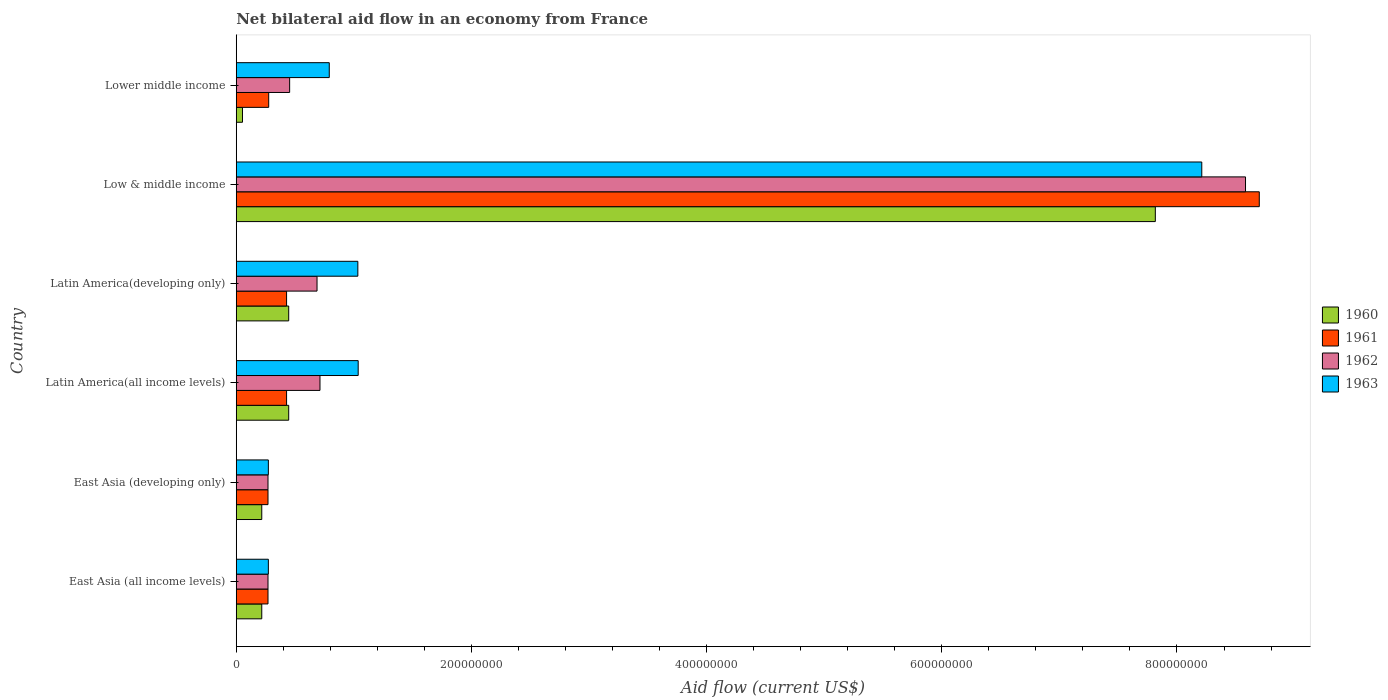How many groups of bars are there?
Offer a terse response. 6. Are the number of bars on each tick of the Y-axis equal?
Provide a short and direct response. Yes. How many bars are there on the 4th tick from the top?
Your response must be concise. 4. How many bars are there on the 6th tick from the bottom?
Provide a succinct answer. 4. What is the label of the 5th group of bars from the top?
Provide a succinct answer. East Asia (developing only). What is the net bilateral aid flow in 1961 in Lower middle income?
Keep it short and to the point. 2.76e+07. Across all countries, what is the maximum net bilateral aid flow in 1961?
Your answer should be very brief. 8.70e+08. Across all countries, what is the minimum net bilateral aid flow in 1963?
Give a very brief answer. 2.73e+07. In which country was the net bilateral aid flow in 1960 minimum?
Make the answer very short. Lower middle income. What is the total net bilateral aid flow in 1961 in the graph?
Offer a terse response. 1.04e+09. What is the difference between the net bilateral aid flow in 1961 in Latin America(all income levels) and the net bilateral aid flow in 1960 in Latin America(developing only)?
Provide a short and direct response. -1.80e+06. What is the average net bilateral aid flow in 1963 per country?
Provide a short and direct response. 1.94e+08. What is the difference between the net bilateral aid flow in 1961 and net bilateral aid flow in 1962 in Low & middle income?
Make the answer very short. 1.17e+07. What is the ratio of the net bilateral aid flow in 1962 in Latin America(all income levels) to that in Low & middle income?
Your answer should be very brief. 0.08. What is the difference between the highest and the second highest net bilateral aid flow in 1961?
Your response must be concise. 8.27e+08. What is the difference between the highest and the lowest net bilateral aid flow in 1962?
Give a very brief answer. 8.31e+08. Is the sum of the net bilateral aid flow in 1963 in East Asia (developing only) and Latin America(all income levels) greater than the maximum net bilateral aid flow in 1961 across all countries?
Provide a short and direct response. No. Is it the case that in every country, the sum of the net bilateral aid flow in 1961 and net bilateral aid flow in 1963 is greater than the sum of net bilateral aid flow in 1962 and net bilateral aid flow in 1960?
Give a very brief answer. No. How many bars are there?
Provide a succinct answer. 24. Are the values on the major ticks of X-axis written in scientific E-notation?
Your answer should be very brief. No. Does the graph contain any zero values?
Ensure brevity in your answer.  No. Does the graph contain grids?
Offer a very short reply. No. What is the title of the graph?
Your answer should be very brief. Net bilateral aid flow in an economy from France. Does "1986" appear as one of the legend labels in the graph?
Give a very brief answer. No. What is the Aid flow (current US$) of 1960 in East Asia (all income levels)?
Make the answer very short. 2.17e+07. What is the Aid flow (current US$) in 1961 in East Asia (all income levels)?
Offer a very short reply. 2.70e+07. What is the Aid flow (current US$) of 1962 in East Asia (all income levels)?
Keep it short and to the point. 2.70e+07. What is the Aid flow (current US$) in 1963 in East Asia (all income levels)?
Your response must be concise. 2.73e+07. What is the Aid flow (current US$) of 1960 in East Asia (developing only)?
Provide a short and direct response. 2.17e+07. What is the Aid flow (current US$) of 1961 in East Asia (developing only)?
Ensure brevity in your answer.  2.70e+07. What is the Aid flow (current US$) of 1962 in East Asia (developing only)?
Give a very brief answer. 2.70e+07. What is the Aid flow (current US$) of 1963 in East Asia (developing only)?
Provide a succinct answer. 2.73e+07. What is the Aid flow (current US$) of 1960 in Latin America(all income levels)?
Provide a short and direct response. 4.46e+07. What is the Aid flow (current US$) in 1961 in Latin America(all income levels)?
Make the answer very short. 4.28e+07. What is the Aid flow (current US$) of 1962 in Latin America(all income levels)?
Offer a terse response. 7.12e+07. What is the Aid flow (current US$) of 1963 in Latin America(all income levels)?
Your answer should be compact. 1.04e+08. What is the Aid flow (current US$) in 1960 in Latin America(developing only)?
Provide a succinct answer. 4.46e+07. What is the Aid flow (current US$) of 1961 in Latin America(developing only)?
Ensure brevity in your answer.  4.28e+07. What is the Aid flow (current US$) in 1962 in Latin America(developing only)?
Your answer should be very brief. 6.87e+07. What is the Aid flow (current US$) of 1963 in Latin America(developing only)?
Provide a short and direct response. 1.03e+08. What is the Aid flow (current US$) of 1960 in Low & middle income?
Offer a very short reply. 7.82e+08. What is the Aid flow (current US$) of 1961 in Low & middle income?
Ensure brevity in your answer.  8.70e+08. What is the Aid flow (current US$) in 1962 in Low & middle income?
Provide a short and direct response. 8.58e+08. What is the Aid flow (current US$) of 1963 in Low & middle income?
Your answer should be very brief. 8.21e+08. What is the Aid flow (current US$) in 1960 in Lower middle income?
Give a very brief answer. 5.30e+06. What is the Aid flow (current US$) in 1961 in Lower middle income?
Ensure brevity in your answer.  2.76e+07. What is the Aid flow (current US$) in 1962 in Lower middle income?
Your response must be concise. 4.54e+07. What is the Aid flow (current US$) in 1963 in Lower middle income?
Offer a very short reply. 7.91e+07. Across all countries, what is the maximum Aid flow (current US$) in 1960?
Provide a succinct answer. 7.82e+08. Across all countries, what is the maximum Aid flow (current US$) in 1961?
Provide a succinct answer. 8.70e+08. Across all countries, what is the maximum Aid flow (current US$) in 1962?
Keep it short and to the point. 8.58e+08. Across all countries, what is the maximum Aid flow (current US$) in 1963?
Ensure brevity in your answer.  8.21e+08. Across all countries, what is the minimum Aid flow (current US$) of 1960?
Your answer should be very brief. 5.30e+06. Across all countries, what is the minimum Aid flow (current US$) in 1961?
Provide a succinct answer. 2.70e+07. Across all countries, what is the minimum Aid flow (current US$) in 1962?
Your answer should be very brief. 2.70e+07. Across all countries, what is the minimum Aid flow (current US$) in 1963?
Make the answer very short. 2.73e+07. What is the total Aid flow (current US$) of 1960 in the graph?
Give a very brief answer. 9.20e+08. What is the total Aid flow (current US$) of 1961 in the graph?
Give a very brief answer. 1.04e+09. What is the total Aid flow (current US$) of 1962 in the graph?
Keep it short and to the point. 1.10e+09. What is the total Aid flow (current US$) of 1963 in the graph?
Make the answer very short. 1.16e+09. What is the difference between the Aid flow (current US$) in 1961 in East Asia (all income levels) and that in East Asia (developing only)?
Ensure brevity in your answer.  0. What is the difference between the Aid flow (current US$) in 1963 in East Asia (all income levels) and that in East Asia (developing only)?
Your answer should be very brief. 0. What is the difference between the Aid flow (current US$) in 1960 in East Asia (all income levels) and that in Latin America(all income levels)?
Provide a succinct answer. -2.29e+07. What is the difference between the Aid flow (current US$) in 1961 in East Asia (all income levels) and that in Latin America(all income levels)?
Give a very brief answer. -1.58e+07. What is the difference between the Aid flow (current US$) of 1962 in East Asia (all income levels) and that in Latin America(all income levels)?
Provide a succinct answer. -4.42e+07. What is the difference between the Aid flow (current US$) in 1963 in East Asia (all income levels) and that in Latin America(all income levels)?
Offer a terse response. -7.64e+07. What is the difference between the Aid flow (current US$) of 1960 in East Asia (all income levels) and that in Latin America(developing only)?
Provide a succinct answer. -2.29e+07. What is the difference between the Aid flow (current US$) in 1961 in East Asia (all income levels) and that in Latin America(developing only)?
Ensure brevity in your answer.  -1.58e+07. What is the difference between the Aid flow (current US$) of 1962 in East Asia (all income levels) and that in Latin America(developing only)?
Provide a succinct answer. -4.17e+07. What is the difference between the Aid flow (current US$) in 1963 in East Asia (all income levels) and that in Latin America(developing only)?
Your answer should be very brief. -7.61e+07. What is the difference between the Aid flow (current US$) of 1960 in East Asia (all income levels) and that in Low & middle income?
Provide a succinct answer. -7.60e+08. What is the difference between the Aid flow (current US$) of 1961 in East Asia (all income levels) and that in Low & middle income?
Ensure brevity in your answer.  -8.43e+08. What is the difference between the Aid flow (current US$) in 1962 in East Asia (all income levels) and that in Low & middle income?
Offer a terse response. -8.31e+08. What is the difference between the Aid flow (current US$) of 1963 in East Asia (all income levels) and that in Low & middle income?
Give a very brief answer. -7.94e+08. What is the difference between the Aid flow (current US$) in 1960 in East Asia (all income levels) and that in Lower middle income?
Make the answer very short. 1.64e+07. What is the difference between the Aid flow (current US$) of 1961 in East Asia (all income levels) and that in Lower middle income?
Make the answer very short. -6.00e+05. What is the difference between the Aid flow (current US$) in 1962 in East Asia (all income levels) and that in Lower middle income?
Your response must be concise. -1.84e+07. What is the difference between the Aid flow (current US$) of 1963 in East Asia (all income levels) and that in Lower middle income?
Your answer should be very brief. -5.18e+07. What is the difference between the Aid flow (current US$) of 1960 in East Asia (developing only) and that in Latin America(all income levels)?
Your answer should be very brief. -2.29e+07. What is the difference between the Aid flow (current US$) in 1961 in East Asia (developing only) and that in Latin America(all income levels)?
Your answer should be compact. -1.58e+07. What is the difference between the Aid flow (current US$) in 1962 in East Asia (developing only) and that in Latin America(all income levels)?
Offer a very short reply. -4.42e+07. What is the difference between the Aid flow (current US$) in 1963 in East Asia (developing only) and that in Latin America(all income levels)?
Provide a short and direct response. -7.64e+07. What is the difference between the Aid flow (current US$) of 1960 in East Asia (developing only) and that in Latin America(developing only)?
Give a very brief answer. -2.29e+07. What is the difference between the Aid flow (current US$) of 1961 in East Asia (developing only) and that in Latin America(developing only)?
Ensure brevity in your answer.  -1.58e+07. What is the difference between the Aid flow (current US$) of 1962 in East Asia (developing only) and that in Latin America(developing only)?
Your answer should be very brief. -4.17e+07. What is the difference between the Aid flow (current US$) in 1963 in East Asia (developing only) and that in Latin America(developing only)?
Your answer should be compact. -7.61e+07. What is the difference between the Aid flow (current US$) of 1960 in East Asia (developing only) and that in Low & middle income?
Keep it short and to the point. -7.60e+08. What is the difference between the Aid flow (current US$) in 1961 in East Asia (developing only) and that in Low & middle income?
Provide a succinct answer. -8.43e+08. What is the difference between the Aid flow (current US$) of 1962 in East Asia (developing only) and that in Low & middle income?
Your response must be concise. -8.31e+08. What is the difference between the Aid flow (current US$) in 1963 in East Asia (developing only) and that in Low & middle income?
Your answer should be very brief. -7.94e+08. What is the difference between the Aid flow (current US$) in 1960 in East Asia (developing only) and that in Lower middle income?
Your answer should be very brief. 1.64e+07. What is the difference between the Aid flow (current US$) in 1961 in East Asia (developing only) and that in Lower middle income?
Provide a short and direct response. -6.00e+05. What is the difference between the Aid flow (current US$) of 1962 in East Asia (developing only) and that in Lower middle income?
Your answer should be compact. -1.84e+07. What is the difference between the Aid flow (current US$) of 1963 in East Asia (developing only) and that in Lower middle income?
Offer a very short reply. -5.18e+07. What is the difference between the Aid flow (current US$) of 1960 in Latin America(all income levels) and that in Latin America(developing only)?
Give a very brief answer. 0. What is the difference between the Aid flow (current US$) of 1961 in Latin America(all income levels) and that in Latin America(developing only)?
Provide a succinct answer. 0. What is the difference between the Aid flow (current US$) in 1962 in Latin America(all income levels) and that in Latin America(developing only)?
Provide a short and direct response. 2.50e+06. What is the difference between the Aid flow (current US$) in 1960 in Latin America(all income levels) and that in Low & middle income?
Ensure brevity in your answer.  -7.37e+08. What is the difference between the Aid flow (current US$) of 1961 in Latin America(all income levels) and that in Low & middle income?
Make the answer very short. -8.27e+08. What is the difference between the Aid flow (current US$) of 1962 in Latin America(all income levels) and that in Low & middle income?
Offer a very short reply. -7.87e+08. What is the difference between the Aid flow (current US$) in 1963 in Latin America(all income levels) and that in Low & middle income?
Provide a short and direct response. -7.17e+08. What is the difference between the Aid flow (current US$) of 1960 in Latin America(all income levels) and that in Lower middle income?
Offer a terse response. 3.93e+07. What is the difference between the Aid flow (current US$) in 1961 in Latin America(all income levels) and that in Lower middle income?
Make the answer very short. 1.52e+07. What is the difference between the Aid flow (current US$) of 1962 in Latin America(all income levels) and that in Lower middle income?
Provide a succinct answer. 2.58e+07. What is the difference between the Aid flow (current US$) of 1963 in Latin America(all income levels) and that in Lower middle income?
Give a very brief answer. 2.46e+07. What is the difference between the Aid flow (current US$) of 1960 in Latin America(developing only) and that in Low & middle income?
Offer a very short reply. -7.37e+08. What is the difference between the Aid flow (current US$) in 1961 in Latin America(developing only) and that in Low & middle income?
Your answer should be compact. -8.27e+08. What is the difference between the Aid flow (current US$) in 1962 in Latin America(developing only) and that in Low & middle income?
Keep it short and to the point. -7.90e+08. What is the difference between the Aid flow (current US$) of 1963 in Latin America(developing only) and that in Low & middle income?
Offer a very short reply. -7.18e+08. What is the difference between the Aid flow (current US$) of 1960 in Latin America(developing only) and that in Lower middle income?
Your answer should be very brief. 3.93e+07. What is the difference between the Aid flow (current US$) of 1961 in Latin America(developing only) and that in Lower middle income?
Provide a short and direct response. 1.52e+07. What is the difference between the Aid flow (current US$) in 1962 in Latin America(developing only) and that in Lower middle income?
Provide a short and direct response. 2.33e+07. What is the difference between the Aid flow (current US$) of 1963 in Latin America(developing only) and that in Lower middle income?
Provide a succinct answer. 2.43e+07. What is the difference between the Aid flow (current US$) in 1960 in Low & middle income and that in Lower middle income?
Give a very brief answer. 7.76e+08. What is the difference between the Aid flow (current US$) of 1961 in Low & middle income and that in Lower middle income?
Ensure brevity in your answer.  8.42e+08. What is the difference between the Aid flow (current US$) in 1962 in Low & middle income and that in Lower middle income?
Make the answer very short. 8.13e+08. What is the difference between the Aid flow (current US$) of 1963 in Low & middle income and that in Lower middle income?
Provide a succinct answer. 7.42e+08. What is the difference between the Aid flow (current US$) of 1960 in East Asia (all income levels) and the Aid flow (current US$) of 1961 in East Asia (developing only)?
Make the answer very short. -5.30e+06. What is the difference between the Aid flow (current US$) of 1960 in East Asia (all income levels) and the Aid flow (current US$) of 1962 in East Asia (developing only)?
Give a very brief answer. -5.30e+06. What is the difference between the Aid flow (current US$) of 1960 in East Asia (all income levels) and the Aid flow (current US$) of 1963 in East Asia (developing only)?
Offer a very short reply. -5.60e+06. What is the difference between the Aid flow (current US$) in 1961 in East Asia (all income levels) and the Aid flow (current US$) in 1962 in East Asia (developing only)?
Make the answer very short. 0. What is the difference between the Aid flow (current US$) in 1962 in East Asia (all income levels) and the Aid flow (current US$) in 1963 in East Asia (developing only)?
Your answer should be compact. -3.00e+05. What is the difference between the Aid flow (current US$) of 1960 in East Asia (all income levels) and the Aid flow (current US$) of 1961 in Latin America(all income levels)?
Your answer should be very brief. -2.11e+07. What is the difference between the Aid flow (current US$) of 1960 in East Asia (all income levels) and the Aid flow (current US$) of 1962 in Latin America(all income levels)?
Offer a very short reply. -4.95e+07. What is the difference between the Aid flow (current US$) of 1960 in East Asia (all income levels) and the Aid flow (current US$) of 1963 in Latin America(all income levels)?
Provide a short and direct response. -8.20e+07. What is the difference between the Aid flow (current US$) of 1961 in East Asia (all income levels) and the Aid flow (current US$) of 1962 in Latin America(all income levels)?
Offer a very short reply. -4.42e+07. What is the difference between the Aid flow (current US$) of 1961 in East Asia (all income levels) and the Aid flow (current US$) of 1963 in Latin America(all income levels)?
Give a very brief answer. -7.67e+07. What is the difference between the Aid flow (current US$) of 1962 in East Asia (all income levels) and the Aid flow (current US$) of 1963 in Latin America(all income levels)?
Offer a very short reply. -7.67e+07. What is the difference between the Aid flow (current US$) in 1960 in East Asia (all income levels) and the Aid flow (current US$) in 1961 in Latin America(developing only)?
Ensure brevity in your answer.  -2.11e+07. What is the difference between the Aid flow (current US$) in 1960 in East Asia (all income levels) and the Aid flow (current US$) in 1962 in Latin America(developing only)?
Provide a succinct answer. -4.70e+07. What is the difference between the Aid flow (current US$) of 1960 in East Asia (all income levels) and the Aid flow (current US$) of 1963 in Latin America(developing only)?
Your answer should be very brief. -8.17e+07. What is the difference between the Aid flow (current US$) in 1961 in East Asia (all income levels) and the Aid flow (current US$) in 1962 in Latin America(developing only)?
Offer a very short reply. -4.17e+07. What is the difference between the Aid flow (current US$) in 1961 in East Asia (all income levels) and the Aid flow (current US$) in 1963 in Latin America(developing only)?
Offer a terse response. -7.64e+07. What is the difference between the Aid flow (current US$) of 1962 in East Asia (all income levels) and the Aid flow (current US$) of 1963 in Latin America(developing only)?
Provide a succinct answer. -7.64e+07. What is the difference between the Aid flow (current US$) of 1960 in East Asia (all income levels) and the Aid flow (current US$) of 1961 in Low & middle income?
Your response must be concise. -8.48e+08. What is the difference between the Aid flow (current US$) in 1960 in East Asia (all income levels) and the Aid flow (current US$) in 1962 in Low & middle income?
Your response must be concise. -8.37e+08. What is the difference between the Aid flow (current US$) in 1960 in East Asia (all income levels) and the Aid flow (current US$) in 1963 in Low & middle income?
Your answer should be compact. -7.99e+08. What is the difference between the Aid flow (current US$) of 1961 in East Asia (all income levels) and the Aid flow (current US$) of 1962 in Low & middle income?
Your response must be concise. -8.31e+08. What is the difference between the Aid flow (current US$) of 1961 in East Asia (all income levels) and the Aid flow (current US$) of 1963 in Low & middle income?
Provide a short and direct response. -7.94e+08. What is the difference between the Aid flow (current US$) in 1962 in East Asia (all income levels) and the Aid flow (current US$) in 1963 in Low & middle income?
Keep it short and to the point. -7.94e+08. What is the difference between the Aid flow (current US$) in 1960 in East Asia (all income levels) and the Aid flow (current US$) in 1961 in Lower middle income?
Make the answer very short. -5.90e+06. What is the difference between the Aid flow (current US$) in 1960 in East Asia (all income levels) and the Aid flow (current US$) in 1962 in Lower middle income?
Offer a terse response. -2.37e+07. What is the difference between the Aid flow (current US$) of 1960 in East Asia (all income levels) and the Aid flow (current US$) of 1963 in Lower middle income?
Make the answer very short. -5.74e+07. What is the difference between the Aid flow (current US$) of 1961 in East Asia (all income levels) and the Aid flow (current US$) of 1962 in Lower middle income?
Your answer should be compact. -1.84e+07. What is the difference between the Aid flow (current US$) in 1961 in East Asia (all income levels) and the Aid flow (current US$) in 1963 in Lower middle income?
Your answer should be compact. -5.21e+07. What is the difference between the Aid flow (current US$) in 1962 in East Asia (all income levels) and the Aid flow (current US$) in 1963 in Lower middle income?
Keep it short and to the point. -5.21e+07. What is the difference between the Aid flow (current US$) of 1960 in East Asia (developing only) and the Aid flow (current US$) of 1961 in Latin America(all income levels)?
Provide a short and direct response. -2.11e+07. What is the difference between the Aid flow (current US$) of 1960 in East Asia (developing only) and the Aid flow (current US$) of 1962 in Latin America(all income levels)?
Offer a very short reply. -4.95e+07. What is the difference between the Aid flow (current US$) of 1960 in East Asia (developing only) and the Aid flow (current US$) of 1963 in Latin America(all income levels)?
Offer a very short reply. -8.20e+07. What is the difference between the Aid flow (current US$) of 1961 in East Asia (developing only) and the Aid flow (current US$) of 1962 in Latin America(all income levels)?
Ensure brevity in your answer.  -4.42e+07. What is the difference between the Aid flow (current US$) of 1961 in East Asia (developing only) and the Aid flow (current US$) of 1963 in Latin America(all income levels)?
Provide a short and direct response. -7.67e+07. What is the difference between the Aid flow (current US$) in 1962 in East Asia (developing only) and the Aid flow (current US$) in 1963 in Latin America(all income levels)?
Provide a short and direct response. -7.67e+07. What is the difference between the Aid flow (current US$) of 1960 in East Asia (developing only) and the Aid flow (current US$) of 1961 in Latin America(developing only)?
Your answer should be compact. -2.11e+07. What is the difference between the Aid flow (current US$) of 1960 in East Asia (developing only) and the Aid flow (current US$) of 1962 in Latin America(developing only)?
Your answer should be very brief. -4.70e+07. What is the difference between the Aid flow (current US$) in 1960 in East Asia (developing only) and the Aid flow (current US$) in 1963 in Latin America(developing only)?
Ensure brevity in your answer.  -8.17e+07. What is the difference between the Aid flow (current US$) of 1961 in East Asia (developing only) and the Aid flow (current US$) of 1962 in Latin America(developing only)?
Ensure brevity in your answer.  -4.17e+07. What is the difference between the Aid flow (current US$) of 1961 in East Asia (developing only) and the Aid flow (current US$) of 1963 in Latin America(developing only)?
Ensure brevity in your answer.  -7.64e+07. What is the difference between the Aid flow (current US$) in 1962 in East Asia (developing only) and the Aid flow (current US$) in 1963 in Latin America(developing only)?
Make the answer very short. -7.64e+07. What is the difference between the Aid flow (current US$) of 1960 in East Asia (developing only) and the Aid flow (current US$) of 1961 in Low & middle income?
Keep it short and to the point. -8.48e+08. What is the difference between the Aid flow (current US$) in 1960 in East Asia (developing only) and the Aid flow (current US$) in 1962 in Low & middle income?
Offer a terse response. -8.37e+08. What is the difference between the Aid flow (current US$) of 1960 in East Asia (developing only) and the Aid flow (current US$) of 1963 in Low & middle income?
Your answer should be compact. -7.99e+08. What is the difference between the Aid flow (current US$) in 1961 in East Asia (developing only) and the Aid flow (current US$) in 1962 in Low & middle income?
Keep it short and to the point. -8.31e+08. What is the difference between the Aid flow (current US$) of 1961 in East Asia (developing only) and the Aid flow (current US$) of 1963 in Low & middle income?
Keep it short and to the point. -7.94e+08. What is the difference between the Aid flow (current US$) of 1962 in East Asia (developing only) and the Aid flow (current US$) of 1963 in Low & middle income?
Give a very brief answer. -7.94e+08. What is the difference between the Aid flow (current US$) in 1960 in East Asia (developing only) and the Aid flow (current US$) in 1961 in Lower middle income?
Your answer should be very brief. -5.90e+06. What is the difference between the Aid flow (current US$) in 1960 in East Asia (developing only) and the Aid flow (current US$) in 1962 in Lower middle income?
Keep it short and to the point. -2.37e+07. What is the difference between the Aid flow (current US$) of 1960 in East Asia (developing only) and the Aid flow (current US$) of 1963 in Lower middle income?
Provide a short and direct response. -5.74e+07. What is the difference between the Aid flow (current US$) of 1961 in East Asia (developing only) and the Aid flow (current US$) of 1962 in Lower middle income?
Your answer should be very brief. -1.84e+07. What is the difference between the Aid flow (current US$) in 1961 in East Asia (developing only) and the Aid flow (current US$) in 1963 in Lower middle income?
Your answer should be compact. -5.21e+07. What is the difference between the Aid flow (current US$) of 1962 in East Asia (developing only) and the Aid flow (current US$) of 1963 in Lower middle income?
Provide a succinct answer. -5.21e+07. What is the difference between the Aid flow (current US$) of 1960 in Latin America(all income levels) and the Aid flow (current US$) of 1961 in Latin America(developing only)?
Keep it short and to the point. 1.80e+06. What is the difference between the Aid flow (current US$) of 1960 in Latin America(all income levels) and the Aid flow (current US$) of 1962 in Latin America(developing only)?
Make the answer very short. -2.41e+07. What is the difference between the Aid flow (current US$) of 1960 in Latin America(all income levels) and the Aid flow (current US$) of 1963 in Latin America(developing only)?
Make the answer very short. -5.88e+07. What is the difference between the Aid flow (current US$) in 1961 in Latin America(all income levels) and the Aid flow (current US$) in 1962 in Latin America(developing only)?
Make the answer very short. -2.59e+07. What is the difference between the Aid flow (current US$) in 1961 in Latin America(all income levels) and the Aid flow (current US$) in 1963 in Latin America(developing only)?
Provide a short and direct response. -6.06e+07. What is the difference between the Aid flow (current US$) in 1962 in Latin America(all income levels) and the Aid flow (current US$) in 1963 in Latin America(developing only)?
Make the answer very short. -3.22e+07. What is the difference between the Aid flow (current US$) of 1960 in Latin America(all income levels) and the Aid flow (current US$) of 1961 in Low & middle income?
Your answer should be very brief. -8.25e+08. What is the difference between the Aid flow (current US$) of 1960 in Latin America(all income levels) and the Aid flow (current US$) of 1962 in Low & middle income?
Provide a succinct answer. -8.14e+08. What is the difference between the Aid flow (current US$) of 1960 in Latin America(all income levels) and the Aid flow (current US$) of 1963 in Low & middle income?
Offer a terse response. -7.76e+08. What is the difference between the Aid flow (current US$) in 1961 in Latin America(all income levels) and the Aid flow (current US$) in 1962 in Low & middle income?
Provide a succinct answer. -8.16e+08. What is the difference between the Aid flow (current US$) of 1961 in Latin America(all income levels) and the Aid flow (current US$) of 1963 in Low & middle income?
Ensure brevity in your answer.  -7.78e+08. What is the difference between the Aid flow (current US$) in 1962 in Latin America(all income levels) and the Aid flow (current US$) in 1963 in Low & middle income?
Provide a short and direct response. -7.50e+08. What is the difference between the Aid flow (current US$) of 1960 in Latin America(all income levels) and the Aid flow (current US$) of 1961 in Lower middle income?
Offer a very short reply. 1.70e+07. What is the difference between the Aid flow (current US$) in 1960 in Latin America(all income levels) and the Aid flow (current US$) in 1962 in Lower middle income?
Provide a short and direct response. -8.00e+05. What is the difference between the Aid flow (current US$) in 1960 in Latin America(all income levels) and the Aid flow (current US$) in 1963 in Lower middle income?
Your response must be concise. -3.45e+07. What is the difference between the Aid flow (current US$) of 1961 in Latin America(all income levels) and the Aid flow (current US$) of 1962 in Lower middle income?
Give a very brief answer. -2.60e+06. What is the difference between the Aid flow (current US$) in 1961 in Latin America(all income levels) and the Aid flow (current US$) in 1963 in Lower middle income?
Provide a succinct answer. -3.63e+07. What is the difference between the Aid flow (current US$) of 1962 in Latin America(all income levels) and the Aid flow (current US$) of 1963 in Lower middle income?
Make the answer very short. -7.90e+06. What is the difference between the Aid flow (current US$) of 1960 in Latin America(developing only) and the Aid flow (current US$) of 1961 in Low & middle income?
Keep it short and to the point. -8.25e+08. What is the difference between the Aid flow (current US$) in 1960 in Latin America(developing only) and the Aid flow (current US$) in 1962 in Low & middle income?
Your answer should be very brief. -8.14e+08. What is the difference between the Aid flow (current US$) in 1960 in Latin America(developing only) and the Aid flow (current US$) in 1963 in Low & middle income?
Provide a short and direct response. -7.76e+08. What is the difference between the Aid flow (current US$) in 1961 in Latin America(developing only) and the Aid flow (current US$) in 1962 in Low & middle income?
Offer a very short reply. -8.16e+08. What is the difference between the Aid flow (current US$) in 1961 in Latin America(developing only) and the Aid flow (current US$) in 1963 in Low & middle income?
Offer a very short reply. -7.78e+08. What is the difference between the Aid flow (current US$) in 1962 in Latin America(developing only) and the Aid flow (current US$) in 1963 in Low & middle income?
Keep it short and to the point. -7.52e+08. What is the difference between the Aid flow (current US$) in 1960 in Latin America(developing only) and the Aid flow (current US$) in 1961 in Lower middle income?
Offer a terse response. 1.70e+07. What is the difference between the Aid flow (current US$) in 1960 in Latin America(developing only) and the Aid flow (current US$) in 1962 in Lower middle income?
Offer a very short reply. -8.00e+05. What is the difference between the Aid flow (current US$) of 1960 in Latin America(developing only) and the Aid flow (current US$) of 1963 in Lower middle income?
Make the answer very short. -3.45e+07. What is the difference between the Aid flow (current US$) in 1961 in Latin America(developing only) and the Aid flow (current US$) in 1962 in Lower middle income?
Give a very brief answer. -2.60e+06. What is the difference between the Aid flow (current US$) of 1961 in Latin America(developing only) and the Aid flow (current US$) of 1963 in Lower middle income?
Your answer should be compact. -3.63e+07. What is the difference between the Aid flow (current US$) in 1962 in Latin America(developing only) and the Aid flow (current US$) in 1963 in Lower middle income?
Your answer should be compact. -1.04e+07. What is the difference between the Aid flow (current US$) of 1960 in Low & middle income and the Aid flow (current US$) of 1961 in Lower middle income?
Give a very brief answer. 7.54e+08. What is the difference between the Aid flow (current US$) in 1960 in Low & middle income and the Aid flow (current US$) in 1962 in Lower middle income?
Keep it short and to the point. 7.36e+08. What is the difference between the Aid flow (current US$) in 1960 in Low & middle income and the Aid flow (current US$) in 1963 in Lower middle income?
Ensure brevity in your answer.  7.02e+08. What is the difference between the Aid flow (current US$) of 1961 in Low & middle income and the Aid flow (current US$) of 1962 in Lower middle income?
Make the answer very short. 8.25e+08. What is the difference between the Aid flow (current US$) of 1961 in Low & middle income and the Aid flow (current US$) of 1963 in Lower middle income?
Your response must be concise. 7.91e+08. What is the difference between the Aid flow (current US$) of 1962 in Low & middle income and the Aid flow (current US$) of 1963 in Lower middle income?
Give a very brief answer. 7.79e+08. What is the average Aid flow (current US$) of 1960 per country?
Your answer should be very brief. 1.53e+08. What is the average Aid flow (current US$) of 1961 per country?
Give a very brief answer. 1.73e+08. What is the average Aid flow (current US$) of 1962 per country?
Provide a succinct answer. 1.83e+08. What is the average Aid flow (current US$) of 1963 per country?
Your answer should be compact. 1.94e+08. What is the difference between the Aid flow (current US$) of 1960 and Aid flow (current US$) of 1961 in East Asia (all income levels)?
Keep it short and to the point. -5.30e+06. What is the difference between the Aid flow (current US$) of 1960 and Aid flow (current US$) of 1962 in East Asia (all income levels)?
Your response must be concise. -5.30e+06. What is the difference between the Aid flow (current US$) in 1960 and Aid flow (current US$) in 1963 in East Asia (all income levels)?
Your answer should be compact. -5.60e+06. What is the difference between the Aid flow (current US$) of 1960 and Aid flow (current US$) of 1961 in East Asia (developing only)?
Give a very brief answer. -5.30e+06. What is the difference between the Aid flow (current US$) in 1960 and Aid flow (current US$) in 1962 in East Asia (developing only)?
Give a very brief answer. -5.30e+06. What is the difference between the Aid flow (current US$) of 1960 and Aid flow (current US$) of 1963 in East Asia (developing only)?
Provide a succinct answer. -5.60e+06. What is the difference between the Aid flow (current US$) in 1961 and Aid flow (current US$) in 1963 in East Asia (developing only)?
Offer a terse response. -3.00e+05. What is the difference between the Aid flow (current US$) in 1960 and Aid flow (current US$) in 1961 in Latin America(all income levels)?
Your answer should be very brief. 1.80e+06. What is the difference between the Aid flow (current US$) in 1960 and Aid flow (current US$) in 1962 in Latin America(all income levels)?
Your answer should be compact. -2.66e+07. What is the difference between the Aid flow (current US$) in 1960 and Aid flow (current US$) in 1963 in Latin America(all income levels)?
Your answer should be very brief. -5.91e+07. What is the difference between the Aid flow (current US$) in 1961 and Aid flow (current US$) in 1962 in Latin America(all income levels)?
Your response must be concise. -2.84e+07. What is the difference between the Aid flow (current US$) of 1961 and Aid flow (current US$) of 1963 in Latin America(all income levels)?
Offer a very short reply. -6.09e+07. What is the difference between the Aid flow (current US$) in 1962 and Aid flow (current US$) in 1963 in Latin America(all income levels)?
Keep it short and to the point. -3.25e+07. What is the difference between the Aid flow (current US$) of 1960 and Aid flow (current US$) of 1961 in Latin America(developing only)?
Offer a terse response. 1.80e+06. What is the difference between the Aid flow (current US$) in 1960 and Aid flow (current US$) in 1962 in Latin America(developing only)?
Provide a short and direct response. -2.41e+07. What is the difference between the Aid flow (current US$) in 1960 and Aid flow (current US$) in 1963 in Latin America(developing only)?
Your answer should be compact. -5.88e+07. What is the difference between the Aid flow (current US$) of 1961 and Aid flow (current US$) of 1962 in Latin America(developing only)?
Offer a very short reply. -2.59e+07. What is the difference between the Aid flow (current US$) in 1961 and Aid flow (current US$) in 1963 in Latin America(developing only)?
Provide a succinct answer. -6.06e+07. What is the difference between the Aid flow (current US$) in 1962 and Aid flow (current US$) in 1963 in Latin America(developing only)?
Offer a very short reply. -3.47e+07. What is the difference between the Aid flow (current US$) of 1960 and Aid flow (current US$) of 1961 in Low & middle income?
Make the answer very short. -8.84e+07. What is the difference between the Aid flow (current US$) in 1960 and Aid flow (current US$) in 1962 in Low & middle income?
Offer a very short reply. -7.67e+07. What is the difference between the Aid flow (current US$) of 1960 and Aid flow (current US$) of 1963 in Low & middle income?
Your answer should be very brief. -3.95e+07. What is the difference between the Aid flow (current US$) in 1961 and Aid flow (current US$) in 1962 in Low & middle income?
Offer a terse response. 1.17e+07. What is the difference between the Aid flow (current US$) of 1961 and Aid flow (current US$) of 1963 in Low & middle income?
Ensure brevity in your answer.  4.89e+07. What is the difference between the Aid flow (current US$) in 1962 and Aid flow (current US$) in 1963 in Low & middle income?
Offer a terse response. 3.72e+07. What is the difference between the Aid flow (current US$) of 1960 and Aid flow (current US$) of 1961 in Lower middle income?
Provide a short and direct response. -2.23e+07. What is the difference between the Aid flow (current US$) of 1960 and Aid flow (current US$) of 1962 in Lower middle income?
Make the answer very short. -4.01e+07. What is the difference between the Aid flow (current US$) of 1960 and Aid flow (current US$) of 1963 in Lower middle income?
Ensure brevity in your answer.  -7.38e+07. What is the difference between the Aid flow (current US$) of 1961 and Aid flow (current US$) of 1962 in Lower middle income?
Your answer should be very brief. -1.78e+07. What is the difference between the Aid flow (current US$) of 1961 and Aid flow (current US$) of 1963 in Lower middle income?
Give a very brief answer. -5.15e+07. What is the difference between the Aid flow (current US$) of 1962 and Aid flow (current US$) of 1963 in Lower middle income?
Provide a short and direct response. -3.37e+07. What is the ratio of the Aid flow (current US$) of 1960 in East Asia (all income levels) to that in East Asia (developing only)?
Make the answer very short. 1. What is the ratio of the Aid flow (current US$) in 1962 in East Asia (all income levels) to that in East Asia (developing only)?
Your answer should be compact. 1. What is the ratio of the Aid flow (current US$) of 1960 in East Asia (all income levels) to that in Latin America(all income levels)?
Provide a succinct answer. 0.49. What is the ratio of the Aid flow (current US$) in 1961 in East Asia (all income levels) to that in Latin America(all income levels)?
Your answer should be compact. 0.63. What is the ratio of the Aid flow (current US$) of 1962 in East Asia (all income levels) to that in Latin America(all income levels)?
Make the answer very short. 0.38. What is the ratio of the Aid flow (current US$) in 1963 in East Asia (all income levels) to that in Latin America(all income levels)?
Make the answer very short. 0.26. What is the ratio of the Aid flow (current US$) in 1960 in East Asia (all income levels) to that in Latin America(developing only)?
Make the answer very short. 0.49. What is the ratio of the Aid flow (current US$) of 1961 in East Asia (all income levels) to that in Latin America(developing only)?
Ensure brevity in your answer.  0.63. What is the ratio of the Aid flow (current US$) in 1962 in East Asia (all income levels) to that in Latin America(developing only)?
Ensure brevity in your answer.  0.39. What is the ratio of the Aid flow (current US$) of 1963 in East Asia (all income levels) to that in Latin America(developing only)?
Ensure brevity in your answer.  0.26. What is the ratio of the Aid flow (current US$) of 1960 in East Asia (all income levels) to that in Low & middle income?
Ensure brevity in your answer.  0.03. What is the ratio of the Aid flow (current US$) in 1961 in East Asia (all income levels) to that in Low & middle income?
Keep it short and to the point. 0.03. What is the ratio of the Aid flow (current US$) in 1962 in East Asia (all income levels) to that in Low & middle income?
Keep it short and to the point. 0.03. What is the ratio of the Aid flow (current US$) of 1963 in East Asia (all income levels) to that in Low & middle income?
Your response must be concise. 0.03. What is the ratio of the Aid flow (current US$) in 1960 in East Asia (all income levels) to that in Lower middle income?
Your response must be concise. 4.09. What is the ratio of the Aid flow (current US$) of 1961 in East Asia (all income levels) to that in Lower middle income?
Provide a succinct answer. 0.98. What is the ratio of the Aid flow (current US$) in 1962 in East Asia (all income levels) to that in Lower middle income?
Your response must be concise. 0.59. What is the ratio of the Aid flow (current US$) in 1963 in East Asia (all income levels) to that in Lower middle income?
Offer a terse response. 0.35. What is the ratio of the Aid flow (current US$) of 1960 in East Asia (developing only) to that in Latin America(all income levels)?
Your answer should be very brief. 0.49. What is the ratio of the Aid flow (current US$) in 1961 in East Asia (developing only) to that in Latin America(all income levels)?
Provide a short and direct response. 0.63. What is the ratio of the Aid flow (current US$) in 1962 in East Asia (developing only) to that in Latin America(all income levels)?
Provide a succinct answer. 0.38. What is the ratio of the Aid flow (current US$) in 1963 in East Asia (developing only) to that in Latin America(all income levels)?
Ensure brevity in your answer.  0.26. What is the ratio of the Aid flow (current US$) in 1960 in East Asia (developing only) to that in Latin America(developing only)?
Your answer should be very brief. 0.49. What is the ratio of the Aid flow (current US$) in 1961 in East Asia (developing only) to that in Latin America(developing only)?
Provide a succinct answer. 0.63. What is the ratio of the Aid flow (current US$) of 1962 in East Asia (developing only) to that in Latin America(developing only)?
Your answer should be compact. 0.39. What is the ratio of the Aid flow (current US$) of 1963 in East Asia (developing only) to that in Latin America(developing only)?
Give a very brief answer. 0.26. What is the ratio of the Aid flow (current US$) in 1960 in East Asia (developing only) to that in Low & middle income?
Offer a very short reply. 0.03. What is the ratio of the Aid flow (current US$) in 1961 in East Asia (developing only) to that in Low & middle income?
Give a very brief answer. 0.03. What is the ratio of the Aid flow (current US$) of 1962 in East Asia (developing only) to that in Low & middle income?
Make the answer very short. 0.03. What is the ratio of the Aid flow (current US$) of 1963 in East Asia (developing only) to that in Low & middle income?
Your answer should be compact. 0.03. What is the ratio of the Aid flow (current US$) in 1960 in East Asia (developing only) to that in Lower middle income?
Ensure brevity in your answer.  4.09. What is the ratio of the Aid flow (current US$) of 1961 in East Asia (developing only) to that in Lower middle income?
Provide a succinct answer. 0.98. What is the ratio of the Aid flow (current US$) in 1962 in East Asia (developing only) to that in Lower middle income?
Keep it short and to the point. 0.59. What is the ratio of the Aid flow (current US$) of 1963 in East Asia (developing only) to that in Lower middle income?
Your answer should be compact. 0.35. What is the ratio of the Aid flow (current US$) in 1961 in Latin America(all income levels) to that in Latin America(developing only)?
Offer a very short reply. 1. What is the ratio of the Aid flow (current US$) in 1962 in Latin America(all income levels) to that in Latin America(developing only)?
Your answer should be compact. 1.04. What is the ratio of the Aid flow (current US$) of 1963 in Latin America(all income levels) to that in Latin America(developing only)?
Your answer should be very brief. 1. What is the ratio of the Aid flow (current US$) of 1960 in Latin America(all income levels) to that in Low & middle income?
Provide a succinct answer. 0.06. What is the ratio of the Aid flow (current US$) in 1961 in Latin America(all income levels) to that in Low & middle income?
Ensure brevity in your answer.  0.05. What is the ratio of the Aid flow (current US$) in 1962 in Latin America(all income levels) to that in Low & middle income?
Offer a very short reply. 0.08. What is the ratio of the Aid flow (current US$) in 1963 in Latin America(all income levels) to that in Low & middle income?
Offer a terse response. 0.13. What is the ratio of the Aid flow (current US$) in 1960 in Latin America(all income levels) to that in Lower middle income?
Keep it short and to the point. 8.42. What is the ratio of the Aid flow (current US$) in 1961 in Latin America(all income levels) to that in Lower middle income?
Make the answer very short. 1.55. What is the ratio of the Aid flow (current US$) of 1962 in Latin America(all income levels) to that in Lower middle income?
Your answer should be compact. 1.57. What is the ratio of the Aid flow (current US$) of 1963 in Latin America(all income levels) to that in Lower middle income?
Ensure brevity in your answer.  1.31. What is the ratio of the Aid flow (current US$) in 1960 in Latin America(developing only) to that in Low & middle income?
Offer a very short reply. 0.06. What is the ratio of the Aid flow (current US$) in 1961 in Latin America(developing only) to that in Low & middle income?
Make the answer very short. 0.05. What is the ratio of the Aid flow (current US$) of 1963 in Latin America(developing only) to that in Low & middle income?
Your response must be concise. 0.13. What is the ratio of the Aid flow (current US$) of 1960 in Latin America(developing only) to that in Lower middle income?
Keep it short and to the point. 8.42. What is the ratio of the Aid flow (current US$) in 1961 in Latin America(developing only) to that in Lower middle income?
Your answer should be very brief. 1.55. What is the ratio of the Aid flow (current US$) of 1962 in Latin America(developing only) to that in Lower middle income?
Make the answer very short. 1.51. What is the ratio of the Aid flow (current US$) of 1963 in Latin America(developing only) to that in Lower middle income?
Offer a terse response. 1.31. What is the ratio of the Aid flow (current US$) of 1960 in Low & middle income to that in Lower middle income?
Your answer should be very brief. 147.47. What is the ratio of the Aid flow (current US$) in 1961 in Low & middle income to that in Lower middle income?
Offer a very short reply. 31.52. What is the ratio of the Aid flow (current US$) in 1962 in Low & middle income to that in Lower middle income?
Give a very brief answer. 18.91. What is the ratio of the Aid flow (current US$) in 1963 in Low & middle income to that in Lower middle income?
Provide a succinct answer. 10.38. What is the difference between the highest and the second highest Aid flow (current US$) of 1960?
Make the answer very short. 7.37e+08. What is the difference between the highest and the second highest Aid flow (current US$) in 1961?
Provide a succinct answer. 8.27e+08. What is the difference between the highest and the second highest Aid flow (current US$) of 1962?
Your answer should be compact. 7.87e+08. What is the difference between the highest and the second highest Aid flow (current US$) of 1963?
Your response must be concise. 7.17e+08. What is the difference between the highest and the lowest Aid flow (current US$) of 1960?
Provide a succinct answer. 7.76e+08. What is the difference between the highest and the lowest Aid flow (current US$) of 1961?
Ensure brevity in your answer.  8.43e+08. What is the difference between the highest and the lowest Aid flow (current US$) in 1962?
Provide a succinct answer. 8.31e+08. What is the difference between the highest and the lowest Aid flow (current US$) of 1963?
Your response must be concise. 7.94e+08. 